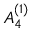Convert formula to latex. <formula><loc_0><loc_0><loc_500><loc_500>{ A } _ { 4 } ^ { ( 1 ) }</formula> 